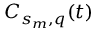<formula> <loc_0><loc_0><loc_500><loc_500>C _ { s _ { m } , q } ( t )</formula> 